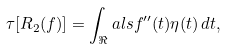Convert formula to latex. <formula><loc_0><loc_0><loc_500><loc_500>\tau [ R _ { 2 } ( f ) ] = \int _ { \Re } a l s f ^ { \prime \prime } ( t ) \eta ( t ) \, d t ,</formula> 